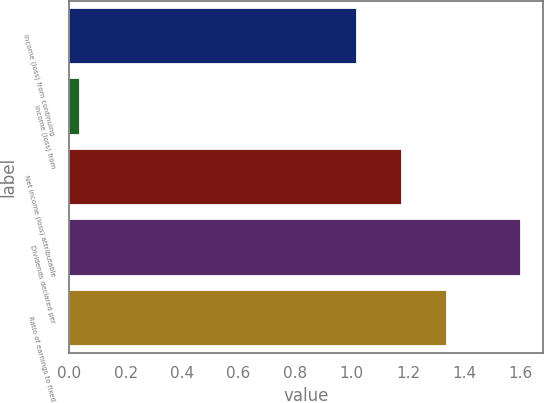<chart> <loc_0><loc_0><loc_500><loc_500><bar_chart><fcel>Income (loss) from continuing<fcel>Income (loss) from<fcel>Net income (loss) attributable<fcel>Dividends declared per<fcel>Ratio of earnings to fixed<nl><fcel>1.02<fcel>0.04<fcel>1.18<fcel>1.6<fcel>1.34<nl></chart> 